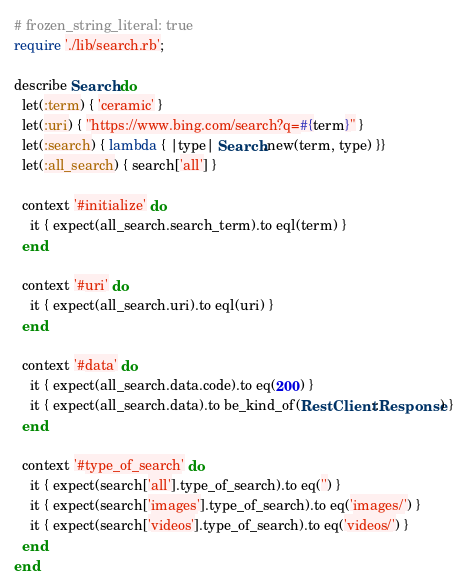<code> <loc_0><loc_0><loc_500><loc_500><_Ruby_># frozen_string_literal: true
require './lib/search.rb';

describe Search do
  let(:term) { 'ceramic' }
  let(:uri) { "https://www.bing.com/search?q=#{term}" }
  let(:search) { lambda { |type| Search.new(term, type) }}
  let(:all_search) { search['all'] }

  context '#initialize' do
    it { expect(all_search.search_term).to eql(term) }
  end

  context '#uri' do
    it { expect(all_search.uri).to eql(uri) }
  end

  context '#data' do
    it { expect(all_search.data.code).to eq(200) }
    it { expect(all_search.data).to be_kind_of(RestClient::Response) }
  end

  context '#type_of_search' do
    it { expect(search['all'].type_of_search).to eq('') }
    it { expect(search['images'].type_of_search).to eq('images/') }
    it { expect(search['videos'].type_of_search).to eq('videos/') }
  end
end
</code> 